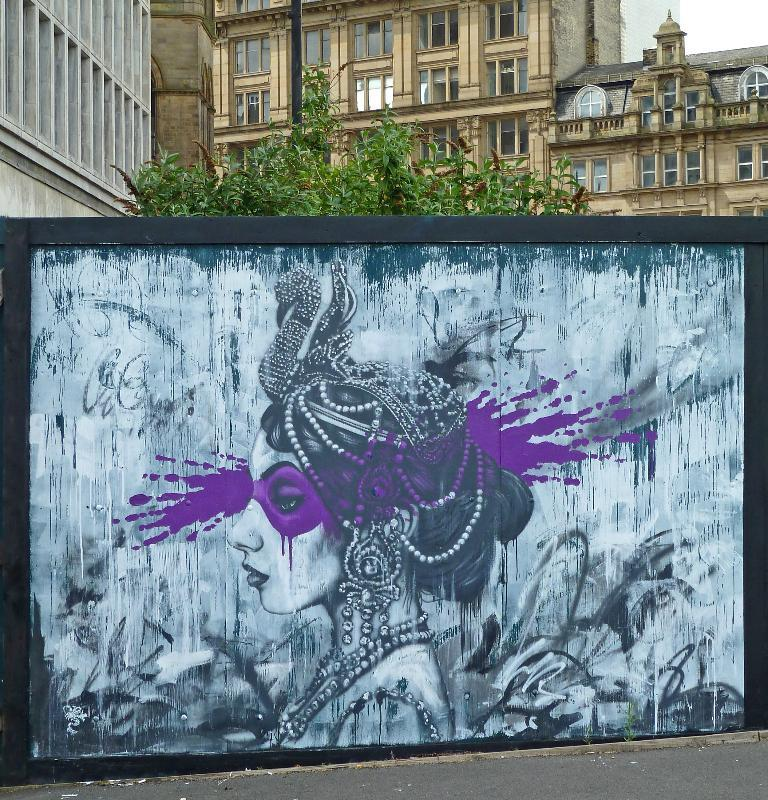What is the main subject in the foreground of the image? There is a wall painting in the foreground of the image. Where was the image likely taken? The image appears to be taken on a road. What can be seen in the background of the image? There are trees, buildings, windows, and the sky visible in the background of the image. What type of maid is depicted in the wall painting? There is no maid depicted in the wall painting; it is a painting of an unspecified subject. What season is it in the image? The season cannot be determined from the image, as there are no specific seasonal indicators present. 